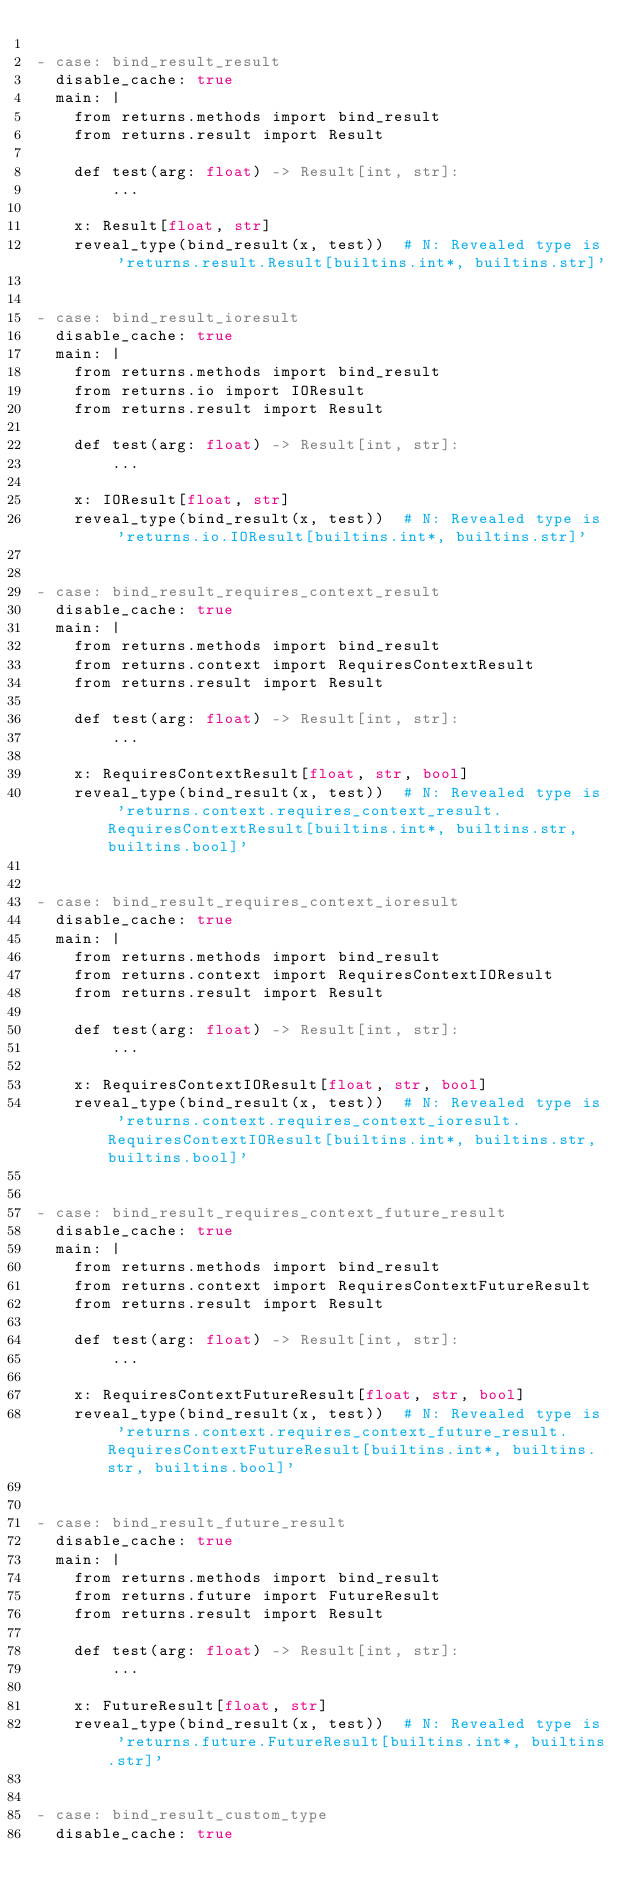Convert code to text. <code><loc_0><loc_0><loc_500><loc_500><_YAML_>
- case: bind_result_result
  disable_cache: true
  main: |
    from returns.methods import bind_result
    from returns.result import Result

    def test(arg: float) -> Result[int, str]:
        ...

    x: Result[float, str]
    reveal_type(bind_result(x, test))  # N: Revealed type is 'returns.result.Result[builtins.int*, builtins.str]'


- case: bind_result_ioresult
  disable_cache: true
  main: |
    from returns.methods import bind_result
    from returns.io import IOResult
    from returns.result import Result

    def test(arg: float) -> Result[int, str]:
        ...

    x: IOResult[float, str]
    reveal_type(bind_result(x, test))  # N: Revealed type is 'returns.io.IOResult[builtins.int*, builtins.str]'


- case: bind_result_requires_context_result
  disable_cache: true
  main: |
    from returns.methods import bind_result
    from returns.context import RequiresContextResult
    from returns.result import Result

    def test(arg: float) -> Result[int, str]:
        ...

    x: RequiresContextResult[float, str, bool]
    reveal_type(bind_result(x, test))  # N: Revealed type is 'returns.context.requires_context_result.RequiresContextResult[builtins.int*, builtins.str, builtins.bool]'


- case: bind_result_requires_context_ioresult
  disable_cache: true
  main: |
    from returns.methods import bind_result
    from returns.context import RequiresContextIOResult
    from returns.result import Result

    def test(arg: float) -> Result[int, str]:
        ...

    x: RequiresContextIOResult[float, str, bool]
    reveal_type(bind_result(x, test))  # N: Revealed type is 'returns.context.requires_context_ioresult.RequiresContextIOResult[builtins.int*, builtins.str, builtins.bool]'


- case: bind_result_requires_context_future_result
  disable_cache: true
  main: |
    from returns.methods import bind_result
    from returns.context import RequiresContextFutureResult
    from returns.result import Result

    def test(arg: float) -> Result[int, str]:
        ...

    x: RequiresContextFutureResult[float, str, bool]
    reveal_type(bind_result(x, test))  # N: Revealed type is 'returns.context.requires_context_future_result.RequiresContextFutureResult[builtins.int*, builtins.str, builtins.bool]'


- case: bind_result_future_result
  disable_cache: true
  main: |
    from returns.methods import bind_result
    from returns.future import FutureResult
    from returns.result import Result

    def test(arg: float) -> Result[int, str]:
        ...

    x: FutureResult[float, str]
    reveal_type(bind_result(x, test))  # N: Revealed type is 'returns.future.FutureResult[builtins.int*, builtins.str]'


- case: bind_result_custom_type
  disable_cache: true</code> 